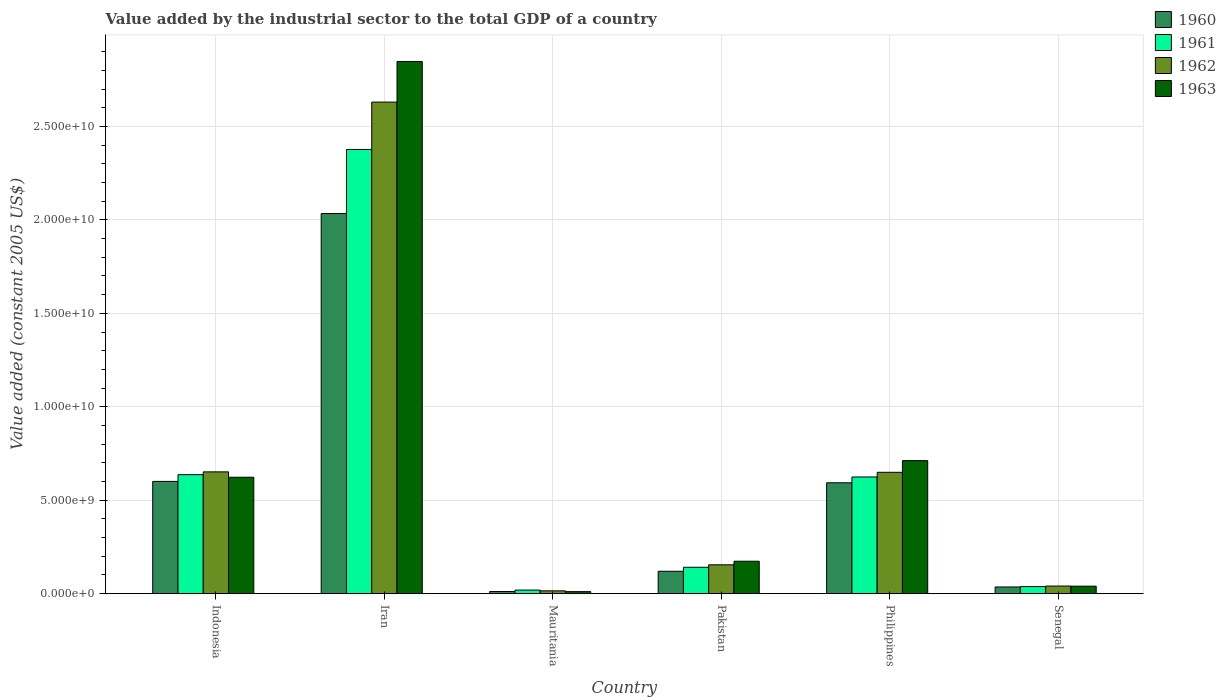What is the label of the 6th group of bars from the left?
Offer a very short reply. Senegal. What is the value added by the industrial sector in 1960 in Senegal?
Provide a short and direct response. 3.58e+08. Across all countries, what is the maximum value added by the industrial sector in 1963?
Your answer should be compact. 2.85e+1. Across all countries, what is the minimum value added by the industrial sector in 1962?
Keep it short and to the point. 1.51e+08. In which country was the value added by the industrial sector in 1960 maximum?
Provide a succinct answer. Iran. In which country was the value added by the industrial sector in 1962 minimum?
Your answer should be very brief. Mauritania. What is the total value added by the industrial sector in 1963 in the graph?
Provide a succinct answer. 4.41e+1. What is the difference between the value added by the industrial sector in 1960 in Iran and that in Philippines?
Your answer should be very brief. 1.44e+1. What is the difference between the value added by the industrial sector in 1960 in Senegal and the value added by the industrial sector in 1961 in Pakistan?
Your answer should be very brief. -1.05e+09. What is the average value added by the industrial sector in 1963 per country?
Provide a short and direct response. 7.34e+09. What is the difference between the value added by the industrial sector of/in 1960 and value added by the industrial sector of/in 1963 in Philippines?
Offer a very short reply. -1.18e+09. In how many countries, is the value added by the industrial sector in 1962 greater than 15000000000 US$?
Make the answer very short. 1. What is the ratio of the value added by the industrial sector in 1962 in Pakistan to that in Philippines?
Offer a terse response. 0.24. Is the value added by the industrial sector in 1961 in Pakistan less than that in Senegal?
Ensure brevity in your answer.  No. Is the difference between the value added by the industrial sector in 1960 in Iran and Pakistan greater than the difference between the value added by the industrial sector in 1963 in Iran and Pakistan?
Make the answer very short. No. What is the difference between the highest and the second highest value added by the industrial sector in 1961?
Your response must be concise. -1.74e+1. What is the difference between the highest and the lowest value added by the industrial sector in 1963?
Offer a terse response. 2.84e+1. In how many countries, is the value added by the industrial sector in 1962 greater than the average value added by the industrial sector in 1962 taken over all countries?
Keep it short and to the point. 1. Is it the case that in every country, the sum of the value added by the industrial sector in 1962 and value added by the industrial sector in 1960 is greater than the value added by the industrial sector in 1961?
Your answer should be very brief. Yes. Does the graph contain grids?
Offer a very short reply. Yes. How many legend labels are there?
Offer a terse response. 4. How are the legend labels stacked?
Your answer should be compact. Vertical. What is the title of the graph?
Make the answer very short. Value added by the industrial sector to the total GDP of a country. What is the label or title of the Y-axis?
Provide a short and direct response. Value added (constant 2005 US$). What is the Value added (constant 2005 US$) of 1960 in Indonesia?
Offer a very short reply. 6.01e+09. What is the Value added (constant 2005 US$) in 1961 in Indonesia?
Ensure brevity in your answer.  6.37e+09. What is the Value added (constant 2005 US$) of 1962 in Indonesia?
Offer a terse response. 6.52e+09. What is the Value added (constant 2005 US$) of 1963 in Indonesia?
Provide a succinct answer. 6.23e+09. What is the Value added (constant 2005 US$) in 1960 in Iran?
Your answer should be compact. 2.03e+1. What is the Value added (constant 2005 US$) of 1961 in Iran?
Provide a succinct answer. 2.38e+1. What is the Value added (constant 2005 US$) in 1962 in Iran?
Offer a very short reply. 2.63e+1. What is the Value added (constant 2005 US$) in 1963 in Iran?
Your answer should be very brief. 2.85e+1. What is the Value added (constant 2005 US$) of 1960 in Mauritania?
Ensure brevity in your answer.  1.15e+08. What is the Value added (constant 2005 US$) in 1961 in Mauritania?
Provide a succinct answer. 1.92e+08. What is the Value added (constant 2005 US$) of 1962 in Mauritania?
Your answer should be compact. 1.51e+08. What is the Value added (constant 2005 US$) of 1963 in Mauritania?
Give a very brief answer. 1.08e+08. What is the Value added (constant 2005 US$) of 1960 in Pakistan?
Make the answer very short. 1.20e+09. What is the Value added (constant 2005 US$) in 1961 in Pakistan?
Provide a short and direct response. 1.41e+09. What is the Value added (constant 2005 US$) of 1962 in Pakistan?
Keep it short and to the point. 1.54e+09. What is the Value added (constant 2005 US$) in 1963 in Pakistan?
Your answer should be very brief. 1.74e+09. What is the Value added (constant 2005 US$) in 1960 in Philippines?
Your answer should be very brief. 5.93e+09. What is the Value added (constant 2005 US$) of 1961 in Philippines?
Provide a succinct answer. 6.24e+09. What is the Value added (constant 2005 US$) in 1962 in Philippines?
Keep it short and to the point. 6.49e+09. What is the Value added (constant 2005 US$) of 1963 in Philippines?
Offer a very short reply. 7.12e+09. What is the Value added (constant 2005 US$) in 1960 in Senegal?
Offer a terse response. 3.58e+08. What is the Value added (constant 2005 US$) of 1961 in Senegal?
Keep it short and to the point. 3.80e+08. What is the Value added (constant 2005 US$) of 1962 in Senegal?
Your response must be concise. 4.08e+08. What is the Value added (constant 2005 US$) in 1963 in Senegal?
Keep it short and to the point. 4.01e+08. Across all countries, what is the maximum Value added (constant 2005 US$) of 1960?
Your response must be concise. 2.03e+1. Across all countries, what is the maximum Value added (constant 2005 US$) in 1961?
Offer a very short reply. 2.38e+1. Across all countries, what is the maximum Value added (constant 2005 US$) in 1962?
Offer a very short reply. 2.63e+1. Across all countries, what is the maximum Value added (constant 2005 US$) in 1963?
Provide a succinct answer. 2.85e+1. Across all countries, what is the minimum Value added (constant 2005 US$) in 1960?
Offer a terse response. 1.15e+08. Across all countries, what is the minimum Value added (constant 2005 US$) in 1961?
Make the answer very short. 1.92e+08. Across all countries, what is the minimum Value added (constant 2005 US$) of 1962?
Offer a very short reply. 1.51e+08. Across all countries, what is the minimum Value added (constant 2005 US$) in 1963?
Provide a succinct answer. 1.08e+08. What is the total Value added (constant 2005 US$) of 1960 in the graph?
Provide a succinct answer. 3.40e+1. What is the total Value added (constant 2005 US$) of 1961 in the graph?
Give a very brief answer. 3.84e+1. What is the total Value added (constant 2005 US$) of 1962 in the graph?
Your answer should be compact. 4.14e+1. What is the total Value added (constant 2005 US$) of 1963 in the graph?
Offer a very short reply. 4.41e+1. What is the difference between the Value added (constant 2005 US$) of 1960 in Indonesia and that in Iran?
Make the answer very short. -1.43e+1. What is the difference between the Value added (constant 2005 US$) in 1961 in Indonesia and that in Iran?
Offer a very short reply. -1.74e+1. What is the difference between the Value added (constant 2005 US$) in 1962 in Indonesia and that in Iran?
Give a very brief answer. -1.98e+1. What is the difference between the Value added (constant 2005 US$) of 1963 in Indonesia and that in Iran?
Ensure brevity in your answer.  -2.22e+1. What is the difference between the Value added (constant 2005 US$) in 1960 in Indonesia and that in Mauritania?
Ensure brevity in your answer.  5.89e+09. What is the difference between the Value added (constant 2005 US$) of 1961 in Indonesia and that in Mauritania?
Ensure brevity in your answer.  6.17e+09. What is the difference between the Value added (constant 2005 US$) of 1962 in Indonesia and that in Mauritania?
Provide a short and direct response. 6.37e+09. What is the difference between the Value added (constant 2005 US$) in 1963 in Indonesia and that in Mauritania?
Provide a short and direct response. 6.12e+09. What is the difference between the Value added (constant 2005 US$) of 1960 in Indonesia and that in Pakistan?
Make the answer very short. 4.81e+09. What is the difference between the Value added (constant 2005 US$) in 1961 in Indonesia and that in Pakistan?
Your answer should be compact. 4.96e+09. What is the difference between the Value added (constant 2005 US$) in 1962 in Indonesia and that in Pakistan?
Keep it short and to the point. 4.97e+09. What is the difference between the Value added (constant 2005 US$) in 1963 in Indonesia and that in Pakistan?
Your response must be concise. 4.49e+09. What is the difference between the Value added (constant 2005 US$) of 1960 in Indonesia and that in Philippines?
Provide a short and direct response. 7.44e+07. What is the difference between the Value added (constant 2005 US$) of 1961 in Indonesia and that in Philippines?
Make the answer very short. 1.23e+08. What is the difference between the Value added (constant 2005 US$) in 1962 in Indonesia and that in Philippines?
Ensure brevity in your answer.  2.37e+07. What is the difference between the Value added (constant 2005 US$) in 1963 in Indonesia and that in Philippines?
Provide a succinct answer. -8.88e+08. What is the difference between the Value added (constant 2005 US$) in 1960 in Indonesia and that in Senegal?
Offer a terse response. 5.65e+09. What is the difference between the Value added (constant 2005 US$) of 1961 in Indonesia and that in Senegal?
Provide a succinct answer. 5.99e+09. What is the difference between the Value added (constant 2005 US$) in 1962 in Indonesia and that in Senegal?
Your response must be concise. 6.11e+09. What is the difference between the Value added (constant 2005 US$) of 1963 in Indonesia and that in Senegal?
Give a very brief answer. 5.83e+09. What is the difference between the Value added (constant 2005 US$) of 1960 in Iran and that in Mauritania?
Provide a succinct answer. 2.02e+1. What is the difference between the Value added (constant 2005 US$) in 1961 in Iran and that in Mauritania?
Offer a very short reply. 2.36e+1. What is the difference between the Value added (constant 2005 US$) in 1962 in Iran and that in Mauritania?
Keep it short and to the point. 2.62e+1. What is the difference between the Value added (constant 2005 US$) of 1963 in Iran and that in Mauritania?
Make the answer very short. 2.84e+1. What is the difference between the Value added (constant 2005 US$) of 1960 in Iran and that in Pakistan?
Offer a terse response. 1.91e+1. What is the difference between the Value added (constant 2005 US$) in 1961 in Iran and that in Pakistan?
Make the answer very short. 2.24e+1. What is the difference between the Value added (constant 2005 US$) in 1962 in Iran and that in Pakistan?
Provide a succinct answer. 2.48e+1. What is the difference between the Value added (constant 2005 US$) of 1963 in Iran and that in Pakistan?
Your answer should be compact. 2.67e+1. What is the difference between the Value added (constant 2005 US$) in 1960 in Iran and that in Philippines?
Your response must be concise. 1.44e+1. What is the difference between the Value added (constant 2005 US$) of 1961 in Iran and that in Philippines?
Ensure brevity in your answer.  1.75e+1. What is the difference between the Value added (constant 2005 US$) in 1962 in Iran and that in Philippines?
Your answer should be compact. 1.98e+1. What is the difference between the Value added (constant 2005 US$) of 1963 in Iran and that in Philippines?
Make the answer very short. 2.14e+1. What is the difference between the Value added (constant 2005 US$) of 1960 in Iran and that in Senegal?
Ensure brevity in your answer.  2.00e+1. What is the difference between the Value added (constant 2005 US$) in 1961 in Iran and that in Senegal?
Give a very brief answer. 2.34e+1. What is the difference between the Value added (constant 2005 US$) in 1962 in Iran and that in Senegal?
Give a very brief answer. 2.59e+1. What is the difference between the Value added (constant 2005 US$) of 1963 in Iran and that in Senegal?
Your answer should be very brief. 2.81e+1. What is the difference between the Value added (constant 2005 US$) in 1960 in Mauritania and that in Pakistan?
Offer a very short reply. -1.08e+09. What is the difference between the Value added (constant 2005 US$) in 1961 in Mauritania and that in Pakistan?
Provide a succinct answer. -1.22e+09. What is the difference between the Value added (constant 2005 US$) of 1962 in Mauritania and that in Pakistan?
Give a very brief answer. -1.39e+09. What is the difference between the Value added (constant 2005 US$) in 1963 in Mauritania and that in Pakistan?
Your answer should be compact. -1.63e+09. What is the difference between the Value added (constant 2005 US$) in 1960 in Mauritania and that in Philippines?
Your answer should be very brief. -5.82e+09. What is the difference between the Value added (constant 2005 US$) in 1961 in Mauritania and that in Philippines?
Make the answer very short. -6.05e+09. What is the difference between the Value added (constant 2005 US$) of 1962 in Mauritania and that in Philippines?
Offer a terse response. -6.34e+09. What is the difference between the Value added (constant 2005 US$) of 1963 in Mauritania and that in Philippines?
Your response must be concise. -7.01e+09. What is the difference between the Value added (constant 2005 US$) of 1960 in Mauritania and that in Senegal?
Ensure brevity in your answer.  -2.42e+08. What is the difference between the Value added (constant 2005 US$) in 1961 in Mauritania and that in Senegal?
Your answer should be compact. -1.88e+08. What is the difference between the Value added (constant 2005 US$) in 1962 in Mauritania and that in Senegal?
Give a very brief answer. -2.56e+08. What is the difference between the Value added (constant 2005 US$) of 1963 in Mauritania and that in Senegal?
Offer a terse response. -2.92e+08. What is the difference between the Value added (constant 2005 US$) of 1960 in Pakistan and that in Philippines?
Offer a very short reply. -4.73e+09. What is the difference between the Value added (constant 2005 US$) of 1961 in Pakistan and that in Philippines?
Provide a succinct answer. -4.83e+09. What is the difference between the Value added (constant 2005 US$) of 1962 in Pakistan and that in Philippines?
Keep it short and to the point. -4.95e+09. What is the difference between the Value added (constant 2005 US$) in 1963 in Pakistan and that in Philippines?
Ensure brevity in your answer.  -5.38e+09. What is the difference between the Value added (constant 2005 US$) of 1960 in Pakistan and that in Senegal?
Ensure brevity in your answer.  8.40e+08. What is the difference between the Value added (constant 2005 US$) in 1961 in Pakistan and that in Senegal?
Keep it short and to the point. 1.03e+09. What is the difference between the Value added (constant 2005 US$) in 1962 in Pakistan and that in Senegal?
Offer a very short reply. 1.14e+09. What is the difference between the Value added (constant 2005 US$) of 1963 in Pakistan and that in Senegal?
Offer a terse response. 1.33e+09. What is the difference between the Value added (constant 2005 US$) of 1960 in Philippines and that in Senegal?
Your answer should be very brief. 5.57e+09. What is the difference between the Value added (constant 2005 US$) in 1961 in Philippines and that in Senegal?
Offer a terse response. 5.86e+09. What is the difference between the Value added (constant 2005 US$) of 1962 in Philippines and that in Senegal?
Provide a short and direct response. 6.09e+09. What is the difference between the Value added (constant 2005 US$) in 1963 in Philippines and that in Senegal?
Ensure brevity in your answer.  6.72e+09. What is the difference between the Value added (constant 2005 US$) in 1960 in Indonesia and the Value added (constant 2005 US$) in 1961 in Iran?
Ensure brevity in your answer.  -1.78e+1. What is the difference between the Value added (constant 2005 US$) of 1960 in Indonesia and the Value added (constant 2005 US$) of 1962 in Iran?
Provide a short and direct response. -2.03e+1. What is the difference between the Value added (constant 2005 US$) in 1960 in Indonesia and the Value added (constant 2005 US$) in 1963 in Iran?
Ensure brevity in your answer.  -2.25e+1. What is the difference between the Value added (constant 2005 US$) in 1961 in Indonesia and the Value added (constant 2005 US$) in 1962 in Iran?
Your answer should be very brief. -1.99e+1. What is the difference between the Value added (constant 2005 US$) of 1961 in Indonesia and the Value added (constant 2005 US$) of 1963 in Iran?
Offer a terse response. -2.21e+1. What is the difference between the Value added (constant 2005 US$) in 1962 in Indonesia and the Value added (constant 2005 US$) in 1963 in Iran?
Offer a terse response. -2.20e+1. What is the difference between the Value added (constant 2005 US$) of 1960 in Indonesia and the Value added (constant 2005 US$) of 1961 in Mauritania?
Provide a short and direct response. 5.81e+09. What is the difference between the Value added (constant 2005 US$) in 1960 in Indonesia and the Value added (constant 2005 US$) in 1962 in Mauritania?
Your answer should be very brief. 5.86e+09. What is the difference between the Value added (constant 2005 US$) of 1960 in Indonesia and the Value added (constant 2005 US$) of 1963 in Mauritania?
Your answer should be very brief. 5.90e+09. What is the difference between the Value added (constant 2005 US$) of 1961 in Indonesia and the Value added (constant 2005 US$) of 1962 in Mauritania?
Make the answer very short. 6.22e+09. What is the difference between the Value added (constant 2005 US$) in 1961 in Indonesia and the Value added (constant 2005 US$) in 1963 in Mauritania?
Make the answer very short. 6.26e+09. What is the difference between the Value added (constant 2005 US$) in 1962 in Indonesia and the Value added (constant 2005 US$) in 1963 in Mauritania?
Provide a short and direct response. 6.41e+09. What is the difference between the Value added (constant 2005 US$) in 1960 in Indonesia and the Value added (constant 2005 US$) in 1961 in Pakistan?
Make the answer very short. 4.60e+09. What is the difference between the Value added (constant 2005 US$) in 1960 in Indonesia and the Value added (constant 2005 US$) in 1962 in Pakistan?
Make the answer very short. 4.46e+09. What is the difference between the Value added (constant 2005 US$) in 1960 in Indonesia and the Value added (constant 2005 US$) in 1963 in Pakistan?
Offer a very short reply. 4.27e+09. What is the difference between the Value added (constant 2005 US$) of 1961 in Indonesia and the Value added (constant 2005 US$) of 1962 in Pakistan?
Your answer should be very brief. 4.82e+09. What is the difference between the Value added (constant 2005 US$) of 1961 in Indonesia and the Value added (constant 2005 US$) of 1963 in Pakistan?
Your answer should be compact. 4.63e+09. What is the difference between the Value added (constant 2005 US$) of 1962 in Indonesia and the Value added (constant 2005 US$) of 1963 in Pakistan?
Provide a succinct answer. 4.78e+09. What is the difference between the Value added (constant 2005 US$) in 1960 in Indonesia and the Value added (constant 2005 US$) in 1961 in Philippines?
Offer a terse response. -2.37e+08. What is the difference between the Value added (constant 2005 US$) of 1960 in Indonesia and the Value added (constant 2005 US$) of 1962 in Philippines?
Your answer should be very brief. -4.86e+08. What is the difference between the Value added (constant 2005 US$) of 1960 in Indonesia and the Value added (constant 2005 US$) of 1963 in Philippines?
Offer a terse response. -1.11e+09. What is the difference between the Value added (constant 2005 US$) in 1961 in Indonesia and the Value added (constant 2005 US$) in 1962 in Philippines?
Offer a very short reply. -1.26e+08. What is the difference between the Value added (constant 2005 US$) in 1961 in Indonesia and the Value added (constant 2005 US$) in 1963 in Philippines?
Ensure brevity in your answer.  -7.50e+08. What is the difference between the Value added (constant 2005 US$) of 1962 in Indonesia and the Value added (constant 2005 US$) of 1963 in Philippines?
Provide a succinct answer. -6.01e+08. What is the difference between the Value added (constant 2005 US$) in 1960 in Indonesia and the Value added (constant 2005 US$) in 1961 in Senegal?
Give a very brief answer. 5.63e+09. What is the difference between the Value added (constant 2005 US$) of 1960 in Indonesia and the Value added (constant 2005 US$) of 1962 in Senegal?
Your answer should be compact. 5.60e+09. What is the difference between the Value added (constant 2005 US$) in 1960 in Indonesia and the Value added (constant 2005 US$) in 1963 in Senegal?
Your answer should be compact. 5.61e+09. What is the difference between the Value added (constant 2005 US$) of 1961 in Indonesia and the Value added (constant 2005 US$) of 1962 in Senegal?
Give a very brief answer. 5.96e+09. What is the difference between the Value added (constant 2005 US$) of 1961 in Indonesia and the Value added (constant 2005 US$) of 1963 in Senegal?
Your answer should be compact. 5.97e+09. What is the difference between the Value added (constant 2005 US$) in 1962 in Indonesia and the Value added (constant 2005 US$) in 1963 in Senegal?
Ensure brevity in your answer.  6.12e+09. What is the difference between the Value added (constant 2005 US$) of 1960 in Iran and the Value added (constant 2005 US$) of 1961 in Mauritania?
Offer a very short reply. 2.01e+1. What is the difference between the Value added (constant 2005 US$) of 1960 in Iran and the Value added (constant 2005 US$) of 1962 in Mauritania?
Your answer should be very brief. 2.02e+1. What is the difference between the Value added (constant 2005 US$) of 1960 in Iran and the Value added (constant 2005 US$) of 1963 in Mauritania?
Provide a short and direct response. 2.02e+1. What is the difference between the Value added (constant 2005 US$) of 1961 in Iran and the Value added (constant 2005 US$) of 1962 in Mauritania?
Your answer should be very brief. 2.36e+1. What is the difference between the Value added (constant 2005 US$) of 1961 in Iran and the Value added (constant 2005 US$) of 1963 in Mauritania?
Give a very brief answer. 2.37e+1. What is the difference between the Value added (constant 2005 US$) of 1962 in Iran and the Value added (constant 2005 US$) of 1963 in Mauritania?
Your answer should be very brief. 2.62e+1. What is the difference between the Value added (constant 2005 US$) of 1960 in Iran and the Value added (constant 2005 US$) of 1961 in Pakistan?
Your response must be concise. 1.89e+1. What is the difference between the Value added (constant 2005 US$) in 1960 in Iran and the Value added (constant 2005 US$) in 1962 in Pakistan?
Offer a very short reply. 1.88e+1. What is the difference between the Value added (constant 2005 US$) in 1960 in Iran and the Value added (constant 2005 US$) in 1963 in Pakistan?
Keep it short and to the point. 1.86e+1. What is the difference between the Value added (constant 2005 US$) of 1961 in Iran and the Value added (constant 2005 US$) of 1962 in Pakistan?
Ensure brevity in your answer.  2.22e+1. What is the difference between the Value added (constant 2005 US$) of 1961 in Iran and the Value added (constant 2005 US$) of 1963 in Pakistan?
Offer a terse response. 2.20e+1. What is the difference between the Value added (constant 2005 US$) of 1962 in Iran and the Value added (constant 2005 US$) of 1963 in Pakistan?
Your response must be concise. 2.46e+1. What is the difference between the Value added (constant 2005 US$) in 1960 in Iran and the Value added (constant 2005 US$) in 1961 in Philippines?
Give a very brief answer. 1.41e+1. What is the difference between the Value added (constant 2005 US$) of 1960 in Iran and the Value added (constant 2005 US$) of 1962 in Philippines?
Keep it short and to the point. 1.38e+1. What is the difference between the Value added (constant 2005 US$) in 1960 in Iran and the Value added (constant 2005 US$) in 1963 in Philippines?
Ensure brevity in your answer.  1.32e+1. What is the difference between the Value added (constant 2005 US$) in 1961 in Iran and the Value added (constant 2005 US$) in 1962 in Philippines?
Keep it short and to the point. 1.73e+1. What is the difference between the Value added (constant 2005 US$) of 1961 in Iran and the Value added (constant 2005 US$) of 1963 in Philippines?
Your answer should be compact. 1.67e+1. What is the difference between the Value added (constant 2005 US$) in 1962 in Iran and the Value added (constant 2005 US$) in 1963 in Philippines?
Give a very brief answer. 1.92e+1. What is the difference between the Value added (constant 2005 US$) in 1960 in Iran and the Value added (constant 2005 US$) in 1961 in Senegal?
Provide a short and direct response. 2.00e+1. What is the difference between the Value added (constant 2005 US$) in 1960 in Iran and the Value added (constant 2005 US$) in 1962 in Senegal?
Provide a short and direct response. 1.99e+1. What is the difference between the Value added (constant 2005 US$) in 1960 in Iran and the Value added (constant 2005 US$) in 1963 in Senegal?
Provide a succinct answer. 1.99e+1. What is the difference between the Value added (constant 2005 US$) of 1961 in Iran and the Value added (constant 2005 US$) of 1962 in Senegal?
Provide a succinct answer. 2.34e+1. What is the difference between the Value added (constant 2005 US$) of 1961 in Iran and the Value added (constant 2005 US$) of 1963 in Senegal?
Ensure brevity in your answer.  2.34e+1. What is the difference between the Value added (constant 2005 US$) of 1962 in Iran and the Value added (constant 2005 US$) of 1963 in Senegal?
Your answer should be very brief. 2.59e+1. What is the difference between the Value added (constant 2005 US$) of 1960 in Mauritania and the Value added (constant 2005 US$) of 1961 in Pakistan?
Your response must be concise. -1.30e+09. What is the difference between the Value added (constant 2005 US$) in 1960 in Mauritania and the Value added (constant 2005 US$) in 1962 in Pakistan?
Make the answer very short. -1.43e+09. What is the difference between the Value added (constant 2005 US$) of 1960 in Mauritania and the Value added (constant 2005 US$) of 1963 in Pakistan?
Keep it short and to the point. -1.62e+09. What is the difference between the Value added (constant 2005 US$) in 1961 in Mauritania and the Value added (constant 2005 US$) in 1962 in Pakistan?
Your answer should be compact. -1.35e+09. What is the difference between the Value added (constant 2005 US$) of 1961 in Mauritania and the Value added (constant 2005 US$) of 1963 in Pakistan?
Make the answer very short. -1.54e+09. What is the difference between the Value added (constant 2005 US$) in 1962 in Mauritania and the Value added (constant 2005 US$) in 1963 in Pakistan?
Your answer should be very brief. -1.58e+09. What is the difference between the Value added (constant 2005 US$) of 1960 in Mauritania and the Value added (constant 2005 US$) of 1961 in Philippines?
Offer a terse response. -6.13e+09. What is the difference between the Value added (constant 2005 US$) in 1960 in Mauritania and the Value added (constant 2005 US$) in 1962 in Philippines?
Offer a terse response. -6.38e+09. What is the difference between the Value added (constant 2005 US$) of 1960 in Mauritania and the Value added (constant 2005 US$) of 1963 in Philippines?
Offer a very short reply. -7.00e+09. What is the difference between the Value added (constant 2005 US$) in 1961 in Mauritania and the Value added (constant 2005 US$) in 1962 in Philippines?
Your response must be concise. -6.30e+09. What is the difference between the Value added (constant 2005 US$) of 1961 in Mauritania and the Value added (constant 2005 US$) of 1963 in Philippines?
Offer a terse response. -6.93e+09. What is the difference between the Value added (constant 2005 US$) in 1962 in Mauritania and the Value added (constant 2005 US$) in 1963 in Philippines?
Your answer should be compact. -6.97e+09. What is the difference between the Value added (constant 2005 US$) in 1960 in Mauritania and the Value added (constant 2005 US$) in 1961 in Senegal?
Give a very brief answer. -2.65e+08. What is the difference between the Value added (constant 2005 US$) in 1960 in Mauritania and the Value added (constant 2005 US$) in 1962 in Senegal?
Provide a succinct answer. -2.92e+08. What is the difference between the Value added (constant 2005 US$) in 1960 in Mauritania and the Value added (constant 2005 US$) in 1963 in Senegal?
Make the answer very short. -2.85e+08. What is the difference between the Value added (constant 2005 US$) in 1961 in Mauritania and the Value added (constant 2005 US$) in 1962 in Senegal?
Provide a short and direct response. -2.15e+08. What is the difference between the Value added (constant 2005 US$) in 1961 in Mauritania and the Value added (constant 2005 US$) in 1963 in Senegal?
Your response must be concise. -2.08e+08. What is the difference between the Value added (constant 2005 US$) of 1962 in Mauritania and the Value added (constant 2005 US$) of 1963 in Senegal?
Give a very brief answer. -2.49e+08. What is the difference between the Value added (constant 2005 US$) in 1960 in Pakistan and the Value added (constant 2005 US$) in 1961 in Philippines?
Offer a terse response. -5.05e+09. What is the difference between the Value added (constant 2005 US$) of 1960 in Pakistan and the Value added (constant 2005 US$) of 1962 in Philippines?
Your response must be concise. -5.30e+09. What is the difference between the Value added (constant 2005 US$) in 1960 in Pakistan and the Value added (constant 2005 US$) in 1963 in Philippines?
Make the answer very short. -5.92e+09. What is the difference between the Value added (constant 2005 US$) of 1961 in Pakistan and the Value added (constant 2005 US$) of 1962 in Philippines?
Provide a short and direct response. -5.08e+09. What is the difference between the Value added (constant 2005 US$) of 1961 in Pakistan and the Value added (constant 2005 US$) of 1963 in Philippines?
Your answer should be compact. -5.71e+09. What is the difference between the Value added (constant 2005 US$) in 1962 in Pakistan and the Value added (constant 2005 US$) in 1963 in Philippines?
Your answer should be very brief. -5.57e+09. What is the difference between the Value added (constant 2005 US$) in 1960 in Pakistan and the Value added (constant 2005 US$) in 1961 in Senegal?
Keep it short and to the point. 8.18e+08. What is the difference between the Value added (constant 2005 US$) in 1960 in Pakistan and the Value added (constant 2005 US$) in 1962 in Senegal?
Your answer should be very brief. 7.91e+08. What is the difference between the Value added (constant 2005 US$) in 1960 in Pakistan and the Value added (constant 2005 US$) in 1963 in Senegal?
Your answer should be compact. 7.98e+08. What is the difference between the Value added (constant 2005 US$) in 1961 in Pakistan and the Value added (constant 2005 US$) in 1962 in Senegal?
Your answer should be very brief. 1.00e+09. What is the difference between the Value added (constant 2005 US$) in 1961 in Pakistan and the Value added (constant 2005 US$) in 1963 in Senegal?
Your response must be concise. 1.01e+09. What is the difference between the Value added (constant 2005 US$) in 1962 in Pakistan and the Value added (constant 2005 US$) in 1963 in Senegal?
Provide a short and direct response. 1.14e+09. What is the difference between the Value added (constant 2005 US$) of 1960 in Philippines and the Value added (constant 2005 US$) of 1961 in Senegal?
Offer a very short reply. 5.55e+09. What is the difference between the Value added (constant 2005 US$) of 1960 in Philippines and the Value added (constant 2005 US$) of 1962 in Senegal?
Make the answer very short. 5.53e+09. What is the difference between the Value added (constant 2005 US$) in 1960 in Philippines and the Value added (constant 2005 US$) in 1963 in Senegal?
Offer a very short reply. 5.53e+09. What is the difference between the Value added (constant 2005 US$) in 1961 in Philippines and the Value added (constant 2005 US$) in 1962 in Senegal?
Offer a very short reply. 5.84e+09. What is the difference between the Value added (constant 2005 US$) in 1961 in Philippines and the Value added (constant 2005 US$) in 1963 in Senegal?
Offer a terse response. 5.84e+09. What is the difference between the Value added (constant 2005 US$) in 1962 in Philippines and the Value added (constant 2005 US$) in 1963 in Senegal?
Ensure brevity in your answer.  6.09e+09. What is the average Value added (constant 2005 US$) in 1960 per country?
Provide a short and direct response. 5.66e+09. What is the average Value added (constant 2005 US$) in 1961 per country?
Offer a very short reply. 6.39e+09. What is the average Value added (constant 2005 US$) of 1962 per country?
Provide a succinct answer. 6.90e+09. What is the average Value added (constant 2005 US$) in 1963 per country?
Offer a very short reply. 7.34e+09. What is the difference between the Value added (constant 2005 US$) in 1960 and Value added (constant 2005 US$) in 1961 in Indonesia?
Give a very brief answer. -3.60e+08. What is the difference between the Value added (constant 2005 US$) in 1960 and Value added (constant 2005 US$) in 1962 in Indonesia?
Keep it short and to the point. -5.10e+08. What is the difference between the Value added (constant 2005 US$) of 1960 and Value added (constant 2005 US$) of 1963 in Indonesia?
Offer a very short reply. -2.22e+08. What is the difference between the Value added (constant 2005 US$) in 1961 and Value added (constant 2005 US$) in 1962 in Indonesia?
Give a very brief answer. -1.50e+08. What is the difference between the Value added (constant 2005 US$) in 1961 and Value added (constant 2005 US$) in 1963 in Indonesia?
Your response must be concise. 1.38e+08. What is the difference between the Value added (constant 2005 US$) of 1962 and Value added (constant 2005 US$) of 1963 in Indonesia?
Your response must be concise. 2.88e+08. What is the difference between the Value added (constant 2005 US$) of 1960 and Value added (constant 2005 US$) of 1961 in Iran?
Your answer should be very brief. -3.43e+09. What is the difference between the Value added (constant 2005 US$) in 1960 and Value added (constant 2005 US$) in 1962 in Iran?
Ensure brevity in your answer.  -5.96e+09. What is the difference between the Value added (constant 2005 US$) of 1960 and Value added (constant 2005 US$) of 1963 in Iran?
Make the answer very short. -8.14e+09. What is the difference between the Value added (constant 2005 US$) of 1961 and Value added (constant 2005 US$) of 1962 in Iran?
Give a very brief answer. -2.53e+09. What is the difference between the Value added (constant 2005 US$) in 1961 and Value added (constant 2005 US$) in 1963 in Iran?
Your answer should be compact. -4.71e+09. What is the difference between the Value added (constant 2005 US$) of 1962 and Value added (constant 2005 US$) of 1963 in Iran?
Offer a terse response. -2.17e+09. What is the difference between the Value added (constant 2005 US$) of 1960 and Value added (constant 2005 US$) of 1961 in Mauritania?
Offer a terse response. -7.68e+07. What is the difference between the Value added (constant 2005 US$) in 1960 and Value added (constant 2005 US$) in 1962 in Mauritania?
Give a very brief answer. -3.59e+07. What is the difference between the Value added (constant 2005 US$) in 1960 and Value added (constant 2005 US$) in 1963 in Mauritania?
Offer a very short reply. 7.13e+06. What is the difference between the Value added (constant 2005 US$) of 1961 and Value added (constant 2005 US$) of 1962 in Mauritania?
Offer a terse response. 4.09e+07. What is the difference between the Value added (constant 2005 US$) in 1961 and Value added (constant 2005 US$) in 1963 in Mauritania?
Your response must be concise. 8.39e+07. What is the difference between the Value added (constant 2005 US$) in 1962 and Value added (constant 2005 US$) in 1963 in Mauritania?
Your response must be concise. 4.31e+07. What is the difference between the Value added (constant 2005 US$) of 1960 and Value added (constant 2005 US$) of 1961 in Pakistan?
Ensure brevity in your answer.  -2.14e+08. What is the difference between the Value added (constant 2005 US$) of 1960 and Value added (constant 2005 US$) of 1962 in Pakistan?
Give a very brief answer. -3.45e+08. What is the difference between the Value added (constant 2005 US$) in 1960 and Value added (constant 2005 US$) in 1963 in Pakistan?
Provide a short and direct response. -5.37e+08. What is the difference between the Value added (constant 2005 US$) in 1961 and Value added (constant 2005 US$) in 1962 in Pakistan?
Your answer should be very brief. -1.32e+08. What is the difference between the Value added (constant 2005 US$) in 1961 and Value added (constant 2005 US$) in 1963 in Pakistan?
Your response must be concise. -3.23e+08. What is the difference between the Value added (constant 2005 US$) in 1962 and Value added (constant 2005 US$) in 1963 in Pakistan?
Your answer should be very brief. -1.92e+08. What is the difference between the Value added (constant 2005 US$) of 1960 and Value added (constant 2005 US$) of 1961 in Philippines?
Give a very brief answer. -3.11e+08. What is the difference between the Value added (constant 2005 US$) of 1960 and Value added (constant 2005 US$) of 1962 in Philippines?
Your answer should be compact. -5.61e+08. What is the difference between the Value added (constant 2005 US$) of 1960 and Value added (constant 2005 US$) of 1963 in Philippines?
Your response must be concise. -1.18e+09. What is the difference between the Value added (constant 2005 US$) of 1961 and Value added (constant 2005 US$) of 1962 in Philippines?
Keep it short and to the point. -2.50e+08. What is the difference between the Value added (constant 2005 US$) of 1961 and Value added (constant 2005 US$) of 1963 in Philippines?
Ensure brevity in your answer.  -8.74e+08. What is the difference between the Value added (constant 2005 US$) in 1962 and Value added (constant 2005 US$) in 1963 in Philippines?
Give a very brief answer. -6.24e+08. What is the difference between the Value added (constant 2005 US$) in 1960 and Value added (constant 2005 US$) in 1961 in Senegal?
Give a very brief answer. -2.25e+07. What is the difference between the Value added (constant 2005 US$) in 1960 and Value added (constant 2005 US$) in 1962 in Senegal?
Ensure brevity in your answer.  -4.98e+07. What is the difference between the Value added (constant 2005 US$) in 1960 and Value added (constant 2005 US$) in 1963 in Senegal?
Your response must be concise. -4.27e+07. What is the difference between the Value added (constant 2005 US$) of 1961 and Value added (constant 2005 US$) of 1962 in Senegal?
Your answer should be compact. -2.72e+07. What is the difference between the Value added (constant 2005 US$) in 1961 and Value added (constant 2005 US$) in 1963 in Senegal?
Your answer should be compact. -2.02e+07. What is the difference between the Value added (constant 2005 US$) in 1962 and Value added (constant 2005 US$) in 1963 in Senegal?
Your answer should be compact. 7.03e+06. What is the ratio of the Value added (constant 2005 US$) of 1960 in Indonesia to that in Iran?
Ensure brevity in your answer.  0.3. What is the ratio of the Value added (constant 2005 US$) in 1961 in Indonesia to that in Iran?
Your answer should be very brief. 0.27. What is the ratio of the Value added (constant 2005 US$) of 1962 in Indonesia to that in Iran?
Provide a short and direct response. 0.25. What is the ratio of the Value added (constant 2005 US$) in 1963 in Indonesia to that in Iran?
Keep it short and to the point. 0.22. What is the ratio of the Value added (constant 2005 US$) in 1960 in Indonesia to that in Mauritania?
Offer a very short reply. 52.07. What is the ratio of the Value added (constant 2005 US$) of 1961 in Indonesia to that in Mauritania?
Make the answer very short. 33.14. What is the ratio of the Value added (constant 2005 US$) of 1962 in Indonesia to that in Mauritania?
Make the answer very short. 43.07. What is the ratio of the Value added (constant 2005 US$) of 1963 in Indonesia to that in Mauritania?
Ensure brevity in your answer.  57.56. What is the ratio of the Value added (constant 2005 US$) in 1960 in Indonesia to that in Pakistan?
Provide a short and direct response. 5.01. What is the ratio of the Value added (constant 2005 US$) in 1961 in Indonesia to that in Pakistan?
Offer a terse response. 4.51. What is the ratio of the Value added (constant 2005 US$) of 1962 in Indonesia to that in Pakistan?
Your answer should be very brief. 4.22. What is the ratio of the Value added (constant 2005 US$) of 1963 in Indonesia to that in Pakistan?
Your response must be concise. 3.59. What is the ratio of the Value added (constant 2005 US$) of 1960 in Indonesia to that in Philippines?
Offer a very short reply. 1.01. What is the ratio of the Value added (constant 2005 US$) of 1961 in Indonesia to that in Philippines?
Your response must be concise. 1.02. What is the ratio of the Value added (constant 2005 US$) in 1962 in Indonesia to that in Philippines?
Offer a very short reply. 1. What is the ratio of the Value added (constant 2005 US$) in 1963 in Indonesia to that in Philippines?
Ensure brevity in your answer.  0.88. What is the ratio of the Value added (constant 2005 US$) in 1960 in Indonesia to that in Senegal?
Provide a short and direct response. 16.79. What is the ratio of the Value added (constant 2005 US$) in 1961 in Indonesia to that in Senegal?
Ensure brevity in your answer.  16.74. What is the ratio of the Value added (constant 2005 US$) in 1962 in Indonesia to that in Senegal?
Make the answer very short. 15.99. What is the ratio of the Value added (constant 2005 US$) of 1963 in Indonesia to that in Senegal?
Ensure brevity in your answer.  15.55. What is the ratio of the Value added (constant 2005 US$) in 1960 in Iran to that in Mauritania?
Offer a terse response. 176.32. What is the ratio of the Value added (constant 2005 US$) in 1961 in Iran to that in Mauritania?
Offer a terse response. 123.7. What is the ratio of the Value added (constant 2005 US$) in 1962 in Iran to that in Mauritania?
Keep it short and to the point. 173.84. What is the ratio of the Value added (constant 2005 US$) in 1963 in Iran to that in Mauritania?
Offer a very short reply. 263.11. What is the ratio of the Value added (constant 2005 US$) of 1960 in Iran to that in Pakistan?
Make the answer very short. 16.98. What is the ratio of the Value added (constant 2005 US$) in 1961 in Iran to that in Pakistan?
Ensure brevity in your answer.  16.84. What is the ratio of the Value added (constant 2005 US$) of 1962 in Iran to that in Pakistan?
Your response must be concise. 17.04. What is the ratio of the Value added (constant 2005 US$) of 1963 in Iran to that in Pakistan?
Ensure brevity in your answer.  16.41. What is the ratio of the Value added (constant 2005 US$) in 1960 in Iran to that in Philippines?
Make the answer very short. 3.43. What is the ratio of the Value added (constant 2005 US$) of 1961 in Iran to that in Philippines?
Keep it short and to the point. 3.81. What is the ratio of the Value added (constant 2005 US$) of 1962 in Iran to that in Philippines?
Keep it short and to the point. 4.05. What is the ratio of the Value added (constant 2005 US$) of 1963 in Iran to that in Philippines?
Your answer should be very brief. 4. What is the ratio of the Value added (constant 2005 US$) in 1960 in Iran to that in Senegal?
Your answer should be very brief. 56.85. What is the ratio of the Value added (constant 2005 US$) of 1961 in Iran to that in Senegal?
Keep it short and to the point. 62.5. What is the ratio of the Value added (constant 2005 US$) of 1962 in Iran to that in Senegal?
Your answer should be very brief. 64.54. What is the ratio of the Value added (constant 2005 US$) of 1963 in Iran to that in Senegal?
Provide a short and direct response. 71.1. What is the ratio of the Value added (constant 2005 US$) of 1960 in Mauritania to that in Pakistan?
Your answer should be very brief. 0.1. What is the ratio of the Value added (constant 2005 US$) of 1961 in Mauritania to that in Pakistan?
Your answer should be very brief. 0.14. What is the ratio of the Value added (constant 2005 US$) in 1962 in Mauritania to that in Pakistan?
Offer a terse response. 0.1. What is the ratio of the Value added (constant 2005 US$) in 1963 in Mauritania to that in Pakistan?
Keep it short and to the point. 0.06. What is the ratio of the Value added (constant 2005 US$) of 1960 in Mauritania to that in Philippines?
Your answer should be very brief. 0.02. What is the ratio of the Value added (constant 2005 US$) in 1961 in Mauritania to that in Philippines?
Provide a succinct answer. 0.03. What is the ratio of the Value added (constant 2005 US$) in 1962 in Mauritania to that in Philippines?
Offer a very short reply. 0.02. What is the ratio of the Value added (constant 2005 US$) of 1963 in Mauritania to that in Philippines?
Make the answer very short. 0.02. What is the ratio of the Value added (constant 2005 US$) of 1960 in Mauritania to that in Senegal?
Give a very brief answer. 0.32. What is the ratio of the Value added (constant 2005 US$) of 1961 in Mauritania to that in Senegal?
Provide a short and direct response. 0.51. What is the ratio of the Value added (constant 2005 US$) in 1962 in Mauritania to that in Senegal?
Offer a very short reply. 0.37. What is the ratio of the Value added (constant 2005 US$) in 1963 in Mauritania to that in Senegal?
Keep it short and to the point. 0.27. What is the ratio of the Value added (constant 2005 US$) in 1960 in Pakistan to that in Philippines?
Your answer should be compact. 0.2. What is the ratio of the Value added (constant 2005 US$) in 1961 in Pakistan to that in Philippines?
Make the answer very short. 0.23. What is the ratio of the Value added (constant 2005 US$) of 1962 in Pakistan to that in Philippines?
Provide a short and direct response. 0.24. What is the ratio of the Value added (constant 2005 US$) in 1963 in Pakistan to that in Philippines?
Your response must be concise. 0.24. What is the ratio of the Value added (constant 2005 US$) in 1960 in Pakistan to that in Senegal?
Offer a very short reply. 3.35. What is the ratio of the Value added (constant 2005 US$) in 1961 in Pakistan to that in Senegal?
Your response must be concise. 3.71. What is the ratio of the Value added (constant 2005 US$) in 1962 in Pakistan to that in Senegal?
Make the answer very short. 3.79. What is the ratio of the Value added (constant 2005 US$) in 1963 in Pakistan to that in Senegal?
Offer a very short reply. 4.33. What is the ratio of the Value added (constant 2005 US$) of 1960 in Philippines to that in Senegal?
Your answer should be compact. 16.58. What is the ratio of the Value added (constant 2005 US$) of 1961 in Philippines to that in Senegal?
Make the answer very short. 16.42. What is the ratio of the Value added (constant 2005 US$) of 1962 in Philippines to that in Senegal?
Keep it short and to the point. 15.93. What is the ratio of the Value added (constant 2005 US$) in 1963 in Philippines to that in Senegal?
Offer a terse response. 17.77. What is the difference between the highest and the second highest Value added (constant 2005 US$) in 1960?
Provide a succinct answer. 1.43e+1. What is the difference between the highest and the second highest Value added (constant 2005 US$) of 1961?
Provide a succinct answer. 1.74e+1. What is the difference between the highest and the second highest Value added (constant 2005 US$) in 1962?
Give a very brief answer. 1.98e+1. What is the difference between the highest and the second highest Value added (constant 2005 US$) of 1963?
Your response must be concise. 2.14e+1. What is the difference between the highest and the lowest Value added (constant 2005 US$) in 1960?
Provide a succinct answer. 2.02e+1. What is the difference between the highest and the lowest Value added (constant 2005 US$) of 1961?
Ensure brevity in your answer.  2.36e+1. What is the difference between the highest and the lowest Value added (constant 2005 US$) in 1962?
Provide a short and direct response. 2.62e+1. What is the difference between the highest and the lowest Value added (constant 2005 US$) in 1963?
Provide a succinct answer. 2.84e+1. 